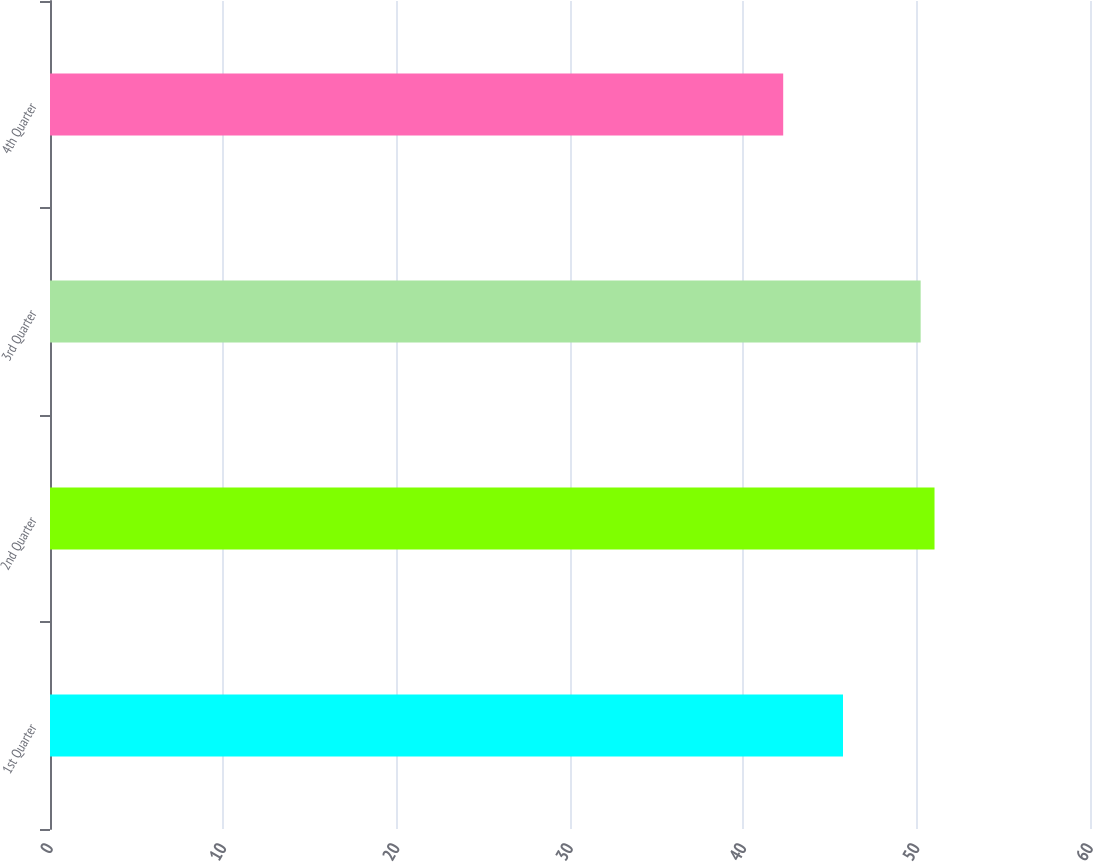<chart> <loc_0><loc_0><loc_500><loc_500><bar_chart><fcel>1st Quarter<fcel>2nd Quarter<fcel>3rd Quarter<fcel>4th Quarter<nl><fcel>45.75<fcel>51.03<fcel>50.23<fcel>42.3<nl></chart> 